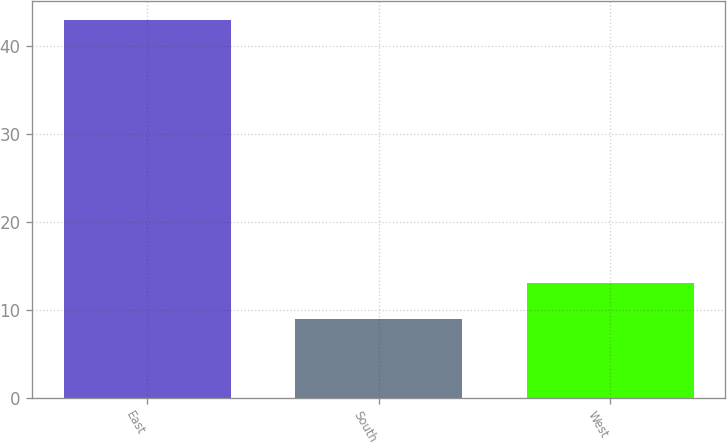Convert chart to OTSL. <chart><loc_0><loc_0><loc_500><loc_500><bar_chart><fcel>East<fcel>South<fcel>West<nl><fcel>43<fcel>9<fcel>13<nl></chart> 